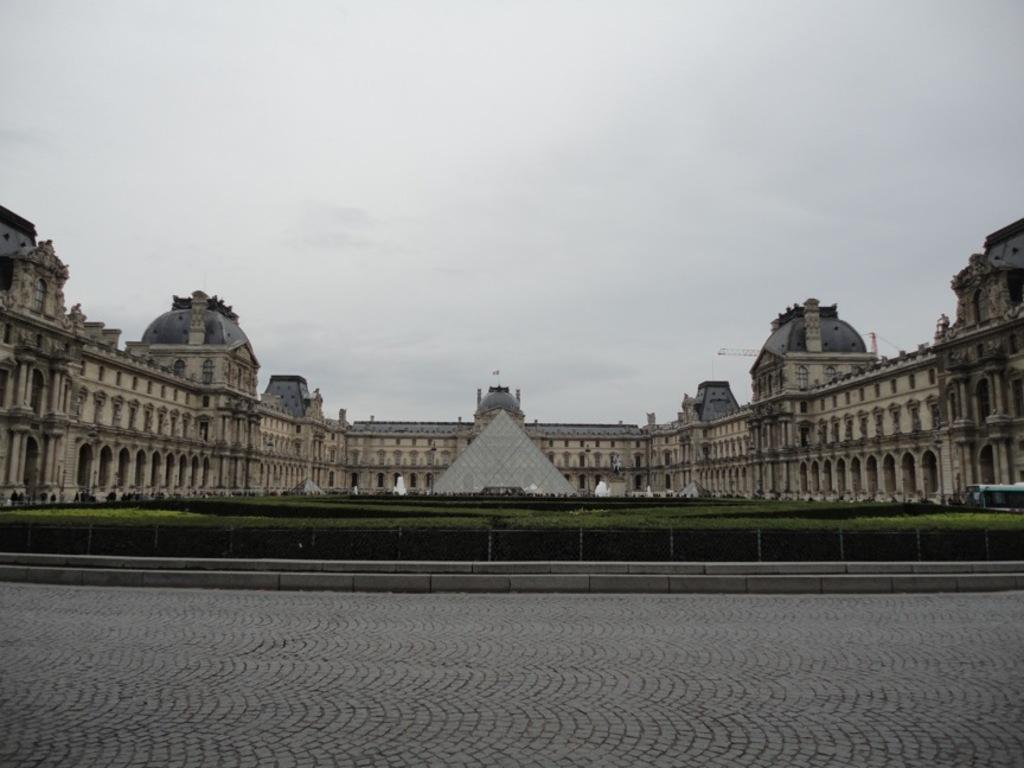Could you give a brief overview of what you see in this image? In this image we can see there is a building and pyramid in front of that, also there are so many plants. 